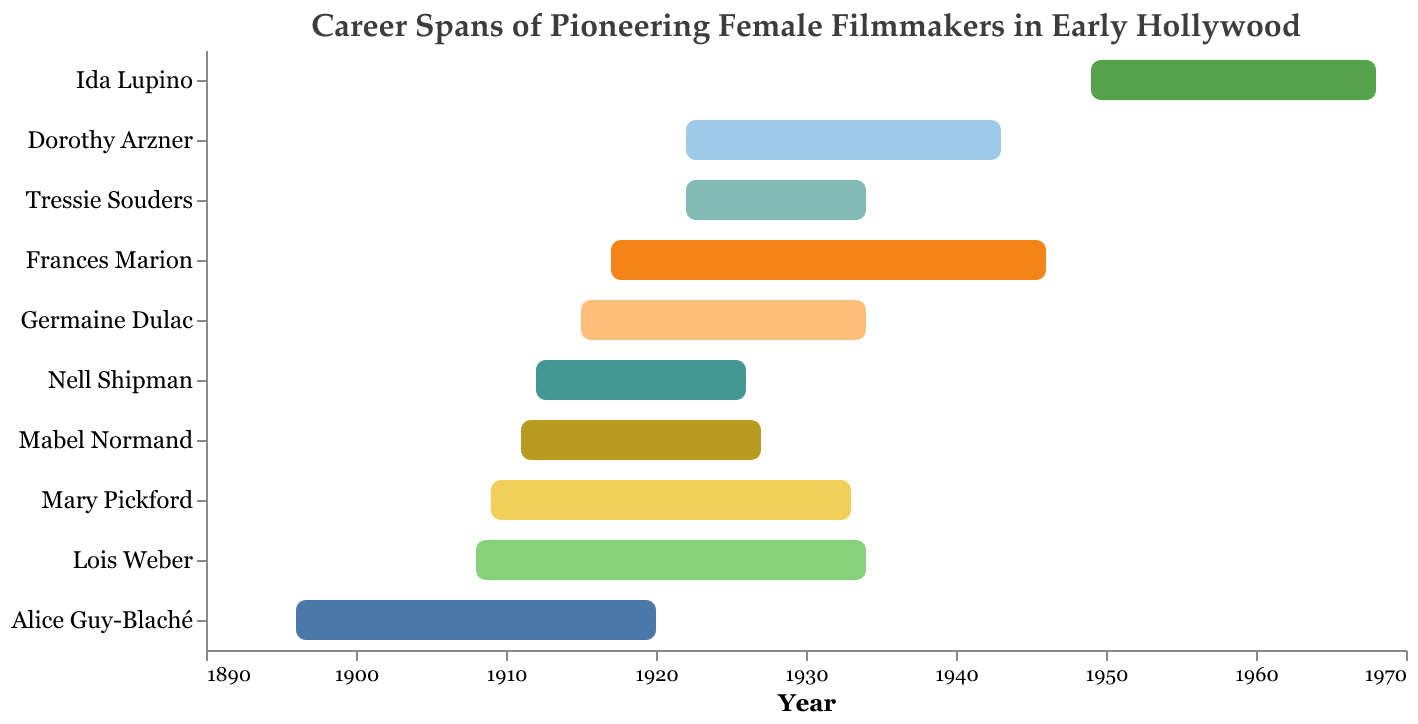Which filmmaker had the longest career span according to the chart? To determine the filmmaker with the longest career span, observe the bars that represent the time each filmmaker was active in the industry. Measure the length from the "Start Year" to the "End Year" and identify the longest one, which is Frances Marion from 1917 to 1946, spanning 29 years.
Answer: Frances Marion How many years did Lois Weber's filmmaking career last? From the chart, Lois Weber's career started in 1908 and ended in 1934. Subtract the start year from the end year: 1934 - 1908 = 26 years.
Answer: 26 years Which filmmaker started their career in Hollywood the earliest? To find the earliest career start, look for the smallest value in the "Start Year" column. Alice Guy-Blaché started in 1896, which is the earliest.
Answer: Alice Guy-Blaché What is the total number of years Mary Pickford and Dorothy Arzner worked in the industry combined? Calculate the individual career spans by subtracting the start year from the end year for both filmmakers. Mary Pickford: 1933 - 1909 = 24 years. Dorothy Arzner: 1943 - 1922 = 21 years. Add both spans: 24 + 21 = 45 years.
Answer: 45 years Who had the shortest career span, and how many years did it last? Identify the filmmaker with the shortest bar. Tressie Souders’ career lasted from 1922 to 1934, which is the shortest span. Calculate the duration: 1934 - 1922 = 12 years.
Answer: Tressie Souders, 12 years Which filmmakers' careers overlapped with both World War I (1914-1918) and World War II (1939-1945)? Check which filmmakers' careers started before 1918 and ended after 1939. Frances Marion’s career from 1917 to 1946 and Dorothy Arzner’s career from 1922 to 1943 overlap with both World Wars.
Answer: Frances Marion and Dorothy Arzner Who began their filmmaking career right after the silent film era (ended around 1929)? The filmmaker who began their career around 1929 is Dorothy Arzner, starting in 1922, which places her career beginning shortly before the sound era started.
Answer: Dorothy Arzner Which filmmakers' careers ended in the same year, and what year was that? Observe the end years. Germaine Dulac, Lois Weber, and Tressie Souders’ careers all ended in the year 1934.
Answer: Germaine Dulac, Lois Weber, and Tressie Souders in 1934 